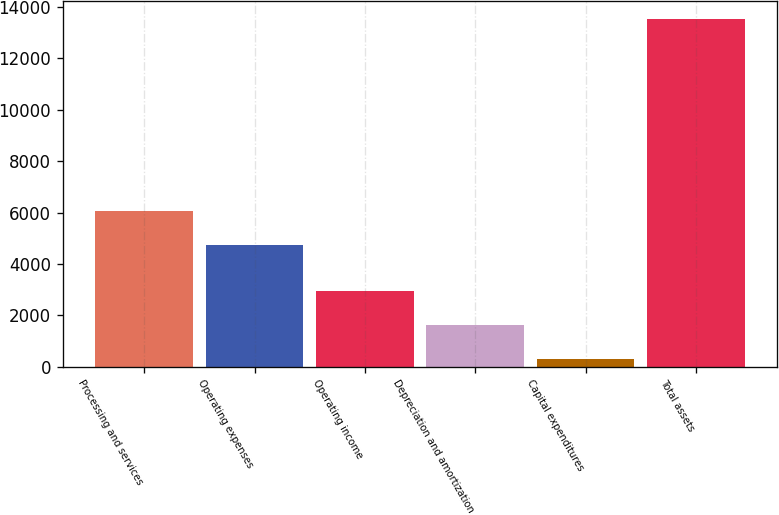<chart> <loc_0><loc_0><loc_500><loc_500><bar_chart><fcel>Processing and services<fcel>Operating expenses<fcel>Operating income<fcel>Depreciation and amortization<fcel>Capital expenditures<fcel>Total assets<nl><fcel>6053.26<fcel>4728.4<fcel>2947.12<fcel>1622.26<fcel>297.4<fcel>13546<nl></chart> 